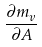<formula> <loc_0><loc_0><loc_500><loc_500>\frac { \partial m _ { v } } { \partial A }</formula> 